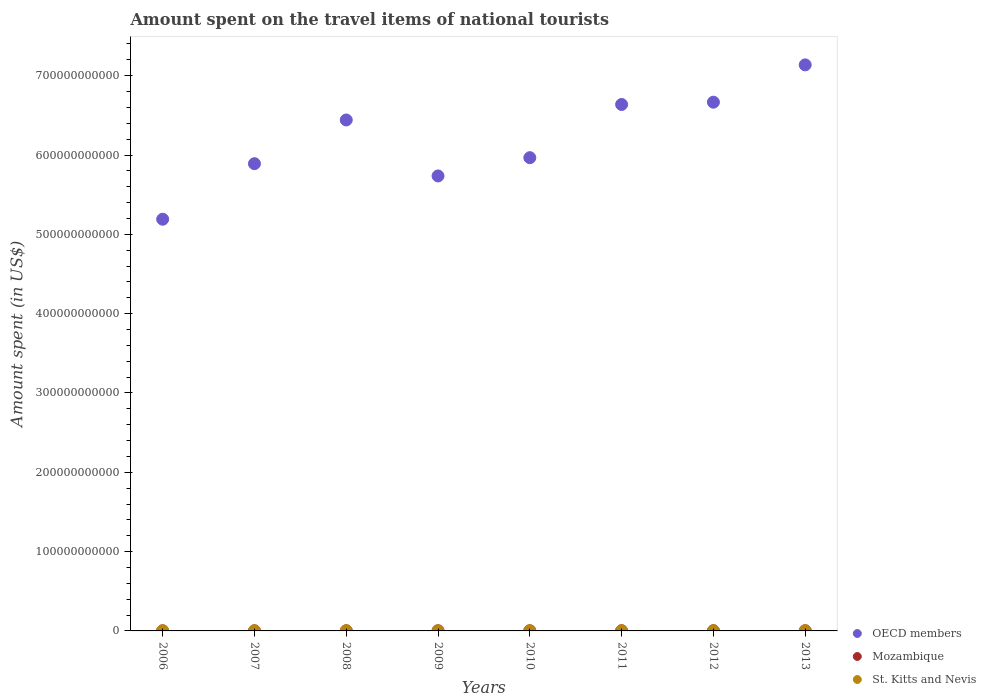How many different coloured dotlines are there?
Ensure brevity in your answer.  3. Is the number of dotlines equal to the number of legend labels?
Offer a terse response. Yes. What is the amount spent on the travel items of national tourists in St. Kitts and Nevis in 2007?
Make the answer very short. 1.25e+08. Across all years, what is the maximum amount spent on the travel items of national tourists in St. Kitts and Nevis?
Ensure brevity in your answer.  1.32e+08. Across all years, what is the minimum amount spent on the travel items of national tourists in St. Kitts and Nevis?
Make the answer very short. 8.30e+07. In which year was the amount spent on the travel items of national tourists in St. Kitts and Nevis maximum?
Your answer should be very brief. 2006. In which year was the amount spent on the travel items of national tourists in OECD members minimum?
Provide a succinct answer. 2006. What is the total amount spent on the travel items of national tourists in St. Kitts and Nevis in the graph?
Offer a terse response. 8.30e+08. What is the difference between the amount spent on the travel items of national tourists in OECD members in 2012 and that in 2013?
Ensure brevity in your answer.  -4.70e+1. What is the difference between the amount spent on the travel items of national tourists in Mozambique in 2013 and the amount spent on the travel items of national tourists in OECD members in 2010?
Give a very brief answer. -5.96e+11. What is the average amount spent on the travel items of national tourists in St. Kitts and Nevis per year?
Provide a short and direct response. 1.04e+08. In the year 2006, what is the difference between the amount spent on the travel items of national tourists in St. Kitts and Nevis and amount spent on the travel items of national tourists in OECD members?
Your answer should be very brief. -5.19e+11. What is the ratio of the amount spent on the travel items of national tourists in Mozambique in 2007 to that in 2009?
Offer a terse response. 0.83. Is the amount spent on the travel items of national tourists in St. Kitts and Nevis in 2009 less than that in 2011?
Offer a very short reply. Yes. What is the difference between the highest and the second highest amount spent on the travel items of national tourists in St. Kitts and Nevis?
Your answer should be compact. 7.00e+06. What is the difference between the highest and the lowest amount spent on the travel items of national tourists in St. Kitts and Nevis?
Ensure brevity in your answer.  4.90e+07. In how many years, is the amount spent on the travel items of national tourists in St. Kitts and Nevis greater than the average amount spent on the travel items of national tourists in St. Kitts and Nevis taken over all years?
Your answer should be very brief. 3. Does the amount spent on the travel items of national tourists in Mozambique monotonically increase over the years?
Offer a very short reply. No. Is the amount spent on the travel items of national tourists in OECD members strictly greater than the amount spent on the travel items of national tourists in St. Kitts and Nevis over the years?
Ensure brevity in your answer.  Yes. How many years are there in the graph?
Give a very brief answer. 8. What is the difference between two consecutive major ticks on the Y-axis?
Provide a short and direct response. 1.00e+11. Does the graph contain any zero values?
Make the answer very short. No. Where does the legend appear in the graph?
Provide a short and direct response. Bottom right. How many legend labels are there?
Your answer should be very brief. 3. What is the title of the graph?
Make the answer very short. Amount spent on the travel items of national tourists. What is the label or title of the Y-axis?
Provide a succinct answer. Amount spent (in US$). What is the Amount spent (in US$) in OECD members in 2006?
Offer a terse response. 5.19e+11. What is the Amount spent (in US$) in Mozambique in 2006?
Provide a short and direct response. 1.40e+08. What is the Amount spent (in US$) of St. Kitts and Nevis in 2006?
Your response must be concise. 1.32e+08. What is the Amount spent (in US$) of OECD members in 2007?
Make the answer very short. 5.89e+11. What is the Amount spent (in US$) in Mozambique in 2007?
Keep it short and to the point. 1.63e+08. What is the Amount spent (in US$) in St. Kitts and Nevis in 2007?
Your answer should be very brief. 1.25e+08. What is the Amount spent (in US$) of OECD members in 2008?
Offer a terse response. 6.44e+11. What is the Amount spent (in US$) in Mozambique in 2008?
Make the answer very short. 1.90e+08. What is the Amount spent (in US$) in St. Kitts and Nevis in 2008?
Offer a very short reply. 1.10e+08. What is the Amount spent (in US$) in OECD members in 2009?
Provide a succinct answer. 5.74e+11. What is the Amount spent (in US$) in Mozambique in 2009?
Provide a succinct answer. 1.96e+08. What is the Amount spent (in US$) in St. Kitts and Nevis in 2009?
Your answer should be very brief. 8.30e+07. What is the Amount spent (in US$) of OECD members in 2010?
Provide a succinct answer. 5.97e+11. What is the Amount spent (in US$) of Mozambique in 2010?
Make the answer very short. 1.97e+08. What is the Amount spent (in US$) in St. Kitts and Nevis in 2010?
Offer a very short reply. 9.00e+07. What is the Amount spent (in US$) of OECD members in 2011?
Offer a terse response. 6.64e+11. What is the Amount spent (in US$) in Mozambique in 2011?
Offer a very short reply. 2.26e+08. What is the Amount spent (in US$) of St. Kitts and Nevis in 2011?
Provide a succinct answer. 9.40e+07. What is the Amount spent (in US$) in OECD members in 2012?
Offer a very short reply. 6.67e+11. What is the Amount spent (in US$) of Mozambique in 2012?
Provide a succinct answer. 2.50e+08. What is the Amount spent (in US$) of St. Kitts and Nevis in 2012?
Your answer should be very brief. 9.50e+07. What is the Amount spent (in US$) in OECD members in 2013?
Provide a short and direct response. 7.14e+11. What is the Amount spent (in US$) of Mozambique in 2013?
Your response must be concise. 2.41e+08. What is the Amount spent (in US$) of St. Kitts and Nevis in 2013?
Provide a short and direct response. 1.01e+08. Across all years, what is the maximum Amount spent (in US$) in OECD members?
Offer a terse response. 7.14e+11. Across all years, what is the maximum Amount spent (in US$) in Mozambique?
Your answer should be compact. 2.50e+08. Across all years, what is the maximum Amount spent (in US$) in St. Kitts and Nevis?
Make the answer very short. 1.32e+08. Across all years, what is the minimum Amount spent (in US$) in OECD members?
Your response must be concise. 5.19e+11. Across all years, what is the minimum Amount spent (in US$) of Mozambique?
Your answer should be compact. 1.40e+08. Across all years, what is the minimum Amount spent (in US$) in St. Kitts and Nevis?
Offer a terse response. 8.30e+07. What is the total Amount spent (in US$) of OECD members in the graph?
Give a very brief answer. 4.97e+12. What is the total Amount spent (in US$) of Mozambique in the graph?
Keep it short and to the point. 1.60e+09. What is the total Amount spent (in US$) in St. Kitts and Nevis in the graph?
Provide a short and direct response. 8.30e+08. What is the difference between the Amount spent (in US$) of OECD members in 2006 and that in 2007?
Provide a succinct answer. -7.00e+1. What is the difference between the Amount spent (in US$) of Mozambique in 2006 and that in 2007?
Offer a very short reply. -2.30e+07. What is the difference between the Amount spent (in US$) of St. Kitts and Nevis in 2006 and that in 2007?
Keep it short and to the point. 7.00e+06. What is the difference between the Amount spent (in US$) of OECD members in 2006 and that in 2008?
Your answer should be very brief. -1.25e+11. What is the difference between the Amount spent (in US$) in Mozambique in 2006 and that in 2008?
Provide a short and direct response. -5.00e+07. What is the difference between the Amount spent (in US$) of St. Kitts and Nevis in 2006 and that in 2008?
Offer a very short reply. 2.20e+07. What is the difference between the Amount spent (in US$) of OECD members in 2006 and that in 2009?
Make the answer very short. -5.46e+1. What is the difference between the Amount spent (in US$) of Mozambique in 2006 and that in 2009?
Give a very brief answer. -5.60e+07. What is the difference between the Amount spent (in US$) of St. Kitts and Nevis in 2006 and that in 2009?
Your response must be concise. 4.90e+07. What is the difference between the Amount spent (in US$) of OECD members in 2006 and that in 2010?
Offer a very short reply. -7.76e+1. What is the difference between the Amount spent (in US$) in Mozambique in 2006 and that in 2010?
Make the answer very short. -5.70e+07. What is the difference between the Amount spent (in US$) in St. Kitts and Nevis in 2006 and that in 2010?
Your answer should be very brief. 4.20e+07. What is the difference between the Amount spent (in US$) of OECD members in 2006 and that in 2011?
Provide a short and direct response. -1.45e+11. What is the difference between the Amount spent (in US$) in Mozambique in 2006 and that in 2011?
Provide a short and direct response. -8.60e+07. What is the difference between the Amount spent (in US$) in St. Kitts and Nevis in 2006 and that in 2011?
Your answer should be very brief. 3.80e+07. What is the difference between the Amount spent (in US$) in OECD members in 2006 and that in 2012?
Give a very brief answer. -1.48e+11. What is the difference between the Amount spent (in US$) of Mozambique in 2006 and that in 2012?
Your answer should be very brief. -1.10e+08. What is the difference between the Amount spent (in US$) of St. Kitts and Nevis in 2006 and that in 2012?
Offer a very short reply. 3.70e+07. What is the difference between the Amount spent (in US$) in OECD members in 2006 and that in 2013?
Offer a terse response. -1.95e+11. What is the difference between the Amount spent (in US$) in Mozambique in 2006 and that in 2013?
Ensure brevity in your answer.  -1.01e+08. What is the difference between the Amount spent (in US$) in St. Kitts and Nevis in 2006 and that in 2013?
Make the answer very short. 3.10e+07. What is the difference between the Amount spent (in US$) in OECD members in 2007 and that in 2008?
Provide a succinct answer. -5.51e+1. What is the difference between the Amount spent (in US$) of Mozambique in 2007 and that in 2008?
Provide a short and direct response. -2.70e+07. What is the difference between the Amount spent (in US$) in St. Kitts and Nevis in 2007 and that in 2008?
Keep it short and to the point. 1.50e+07. What is the difference between the Amount spent (in US$) of OECD members in 2007 and that in 2009?
Offer a very short reply. 1.55e+1. What is the difference between the Amount spent (in US$) in Mozambique in 2007 and that in 2009?
Offer a very short reply. -3.30e+07. What is the difference between the Amount spent (in US$) in St. Kitts and Nevis in 2007 and that in 2009?
Offer a terse response. 4.20e+07. What is the difference between the Amount spent (in US$) of OECD members in 2007 and that in 2010?
Offer a terse response. -7.57e+09. What is the difference between the Amount spent (in US$) of Mozambique in 2007 and that in 2010?
Provide a succinct answer. -3.40e+07. What is the difference between the Amount spent (in US$) of St. Kitts and Nevis in 2007 and that in 2010?
Offer a very short reply. 3.50e+07. What is the difference between the Amount spent (in US$) in OECD members in 2007 and that in 2011?
Give a very brief answer. -7.46e+1. What is the difference between the Amount spent (in US$) of Mozambique in 2007 and that in 2011?
Provide a short and direct response. -6.30e+07. What is the difference between the Amount spent (in US$) of St. Kitts and Nevis in 2007 and that in 2011?
Your answer should be very brief. 3.10e+07. What is the difference between the Amount spent (in US$) in OECD members in 2007 and that in 2012?
Your response must be concise. -7.75e+1. What is the difference between the Amount spent (in US$) in Mozambique in 2007 and that in 2012?
Your response must be concise. -8.70e+07. What is the difference between the Amount spent (in US$) in St. Kitts and Nevis in 2007 and that in 2012?
Make the answer very short. 3.00e+07. What is the difference between the Amount spent (in US$) in OECD members in 2007 and that in 2013?
Provide a short and direct response. -1.25e+11. What is the difference between the Amount spent (in US$) of Mozambique in 2007 and that in 2013?
Give a very brief answer. -7.80e+07. What is the difference between the Amount spent (in US$) of St. Kitts and Nevis in 2007 and that in 2013?
Keep it short and to the point. 2.40e+07. What is the difference between the Amount spent (in US$) of OECD members in 2008 and that in 2009?
Make the answer very short. 7.06e+1. What is the difference between the Amount spent (in US$) of Mozambique in 2008 and that in 2009?
Ensure brevity in your answer.  -6.00e+06. What is the difference between the Amount spent (in US$) of St. Kitts and Nevis in 2008 and that in 2009?
Offer a very short reply. 2.70e+07. What is the difference between the Amount spent (in US$) of OECD members in 2008 and that in 2010?
Give a very brief answer. 4.75e+1. What is the difference between the Amount spent (in US$) in Mozambique in 2008 and that in 2010?
Your answer should be very brief. -7.00e+06. What is the difference between the Amount spent (in US$) in St. Kitts and Nevis in 2008 and that in 2010?
Offer a very short reply. 2.00e+07. What is the difference between the Amount spent (in US$) of OECD members in 2008 and that in 2011?
Keep it short and to the point. -1.95e+1. What is the difference between the Amount spent (in US$) in Mozambique in 2008 and that in 2011?
Your answer should be compact. -3.60e+07. What is the difference between the Amount spent (in US$) of St. Kitts and Nevis in 2008 and that in 2011?
Make the answer very short. 1.60e+07. What is the difference between the Amount spent (in US$) of OECD members in 2008 and that in 2012?
Ensure brevity in your answer.  -2.24e+1. What is the difference between the Amount spent (in US$) in Mozambique in 2008 and that in 2012?
Your answer should be compact. -6.00e+07. What is the difference between the Amount spent (in US$) of St. Kitts and Nevis in 2008 and that in 2012?
Ensure brevity in your answer.  1.50e+07. What is the difference between the Amount spent (in US$) of OECD members in 2008 and that in 2013?
Offer a terse response. -6.95e+1. What is the difference between the Amount spent (in US$) of Mozambique in 2008 and that in 2013?
Provide a short and direct response. -5.10e+07. What is the difference between the Amount spent (in US$) in St. Kitts and Nevis in 2008 and that in 2013?
Offer a terse response. 9.00e+06. What is the difference between the Amount spent (in US$) in OECD members in 2009 and that in 2010?
Offer a very short reply. -2.30e+1. What is the difference between the Amount spent (in US$) of St. Kitts and Nevis in 2009 and that in 2010?
Ensure brevity in your answer.  -7.00e+06. What is the difference between the Amount spent (in US$) of OECD members in 2009 and that in 2011?
Your answer should be very brief. -9.01e+1. What is the difference between the Amount spent (in US$) in Mozambique in 2009 and that in 2011?
Ensure brevity in your answer.  -3.00e+07. What is the difference between the Amount spent (in US$) in St. Kitts and Nevis in 2009 and that in 2011?
Provide a succinct answer. -1.10e+07. What is the difference between the Amount spent (in US$) in OECD members in 2009 and that in 2012?
Make the answer very short. -9.30e+1. What is the difference between the Amount spent (in US$) in Mozambique in 2009 and that in 2012?
Provide a succinct answer. -5.40e+07. What is the difference between the Amount spent (in US$) of St. Kitts and Nevis in 2009 and that in 2012?
Keep it short and to the point. -1.20e+07. What is the difference between the Amount spent (in US$) of OECD members in 2009 and that in 2013?
Keep it short and to the point. -1.40e+11. What is the difference between the Amount spent (in US$) in Mozambique in 2009 and that in 2013?
Offer a terse response. -4.50e+07. What is the difference between the Amount spent (in US$) of St. Kitts and Nevis in 2009 and that in 2013?
Your response must be concise. -1.80e+07. What is the difference between the Amount spent (in US$) in OECD members in 2010 and that in 2011?
Ensure brevity in your answer.  -6.71e+1. What is the difference between the Amount spent (in US$) of Mozambique in 2010 and that in 2011?
Provide a succinct answer. -2.90e+07. What is the difference between the Amount spent (in US$) of OECD members in 2010 and that in 2012?
Ensure brevity in your answer.  -7.00e+1. What is the difference between the Amount spent (in US$) in Mozambique in 2010 and that in 2012?
Keep it short and to the point. -5.30e+07. What is the difference between the Amount spent (in US$) of St. Kitts and Nevis in 2010 and that in 2012?
Your answer should be very brief. -5.00e+06. What is the difference between the Amount spent (in US$) of OECD members in 2010 and that in 2013?
Offer a terse response. -1.17e+11. What is the difference between the Amount spent (in US$) of Mozambique in 2010 and that in 2013?
Your answer should be compact. -4.40e+07. What is the difference between the Amount spent (in US$) in St. Kitts and Nevis in 2010 and that in 2013?
Keep it short and to the point. -1.10e+07. What is the difference between the Amount spent (in US$) of OECD members in 2011 and that in 2012?
Provide a succinct answer. -2.89e+09. What is the difference between the Amount spent (in US$) of Mozambique in 2011 and that in 2012?
Your answer should be very brief. -2.40e+07. What is the difference between the Amount spent (in US$) of OECD members in 2011 and that in 2013?
Your answer should be compact. -4.99e+1. What is the difference between the Amount spent (in US$) of Mozambique in 2011 and that in 2013?
Provide a short and direct response. -1.50e+07. What is the difference between the Amount spent (in US$) in St. Kitts and Nevis in 2011 and that in 2013?
Offer a very short reply. -7.00e+06. What is the difference between the Amount spent (in US$) in OECD members in 2012 and that in 2013?
Provide a succinct answer. -4.70e+1. What is the difference between the Amount spent (in US$) of Mozambique in 2012 and that in 2013?
Provide a succinct answer. 9.00e+06. What is the difference between the Amount spent (in US$) in St. Kitts and Nevis in 2012 and that in 2013?
Keep it short and to the point. -6.00e+06. What is the difference between the Amount spent (in US$) of OECD members in 2006 and the Amount spent (in US$) of Mozambique in 2007?
Your response must be concise. 5.19e+11. What is the difference between the Amount spent (in US$) in OECD members in 2006 and the Amount spent (in US$) in St. Kitts and Nevis in 2007?
Keep it short and to the point. 5.19e+11. What is the difference between the Amount spent (in US$) of Mozambique in 2006 and the Amount spent (in US$) of St. Kitts and Nevis in 2007?
Ensure brevity in your answer.  1.50e+07. What is the difference between the Amount spent (in US$) in OECD members in 2006 and the Amount spent (in US$) in Mozambique in 2008?
Your response must be concise. 5.19e+11. What is the difference between the Amount spent (in US$) in OECD members in 2006 and the Amount spent (in US$) in St. Kitts and Nevis in 2008?
Your answer should be compact. 5.19e+11. What is the difference between the Amount spent (in US$) of Mozambique in 2006 and the Amount spent (in US$) of St. Kitts and Nevis in 2008?
Your answer should be very brief. 3.00e+07. What is the difference between the Amount spent (in US$) in OECD members in 2006 and the Amount spent (in US$) in Mozambique in 2009?
Keep it short and to the point. 5.19e+11. What is the difference between the Amount spent (in US$) of OECD members in 2006 and the Amount spent (in US$) of St. Kitts and Nevis in 2009?
Keep it short and to the point. 5.19e+11. What is the difference between the Amount spent (in US$) in Mozambique in 2006 and the Amount spent (in US$) in St. Kitts and Nevis in 2009?
Ensure brevity in your answer.  5.70e+07. What is the difference between the Amount spent (in US$) in OECD members in 2006 and the Amount spent (in US$) in Mozambique in 2010?
Ensure brevity in your answer.  5.19e+11. What is the difference between the Amount spent (in US$) of OECD members in 2006 and the Amount spent (in US$) of St. Kitts and Nevis in 2010?
Ensure brevity in your answer.  5.19e+11. What is the difference between the Amount spent (in US$) of Mozambique in 2006 and the Amount spent (in US$) of St. Kitts and Nevis in 2010?
Offer a very short reply. 5.00e+07. What is the difference between the Amount spent (in US$) of OECD members in 2006 and the Amount spent (in US$) of Mozambique in 2011?
Your answer should be very brief. 5.19e+11. What is the difference between the Amount spent (in US$) in OECD members in 2006 and the Amount spent (in US$) in St. Kitts and Nevis in 2011?
Provide a short and direct response. 5.19e+11. What is the difference between the Amount spent (in US$) of Mozambique in 2006 and the Amount spent (in US$) of St. Kitts and Nevis in 2011?
Keep it short and to the point. 4.60e+07. What is the difference between the Amount spent (in US$) in OECD members in 2006 and the Amount spent (in US$) in Mozambique in 2012?
Provide a short and direct response. 5.19e+11. What is the difference between the Amount spent (in US$) of OECD members in 2006 and the Amount spent (in US$) of St. Kitts and Nevis in 2012?
Your response must be concise. 5.19e+11. What is the difference between the Amount spent (in US$) in Mozambique in 2006 and the Amount spent (in US$) in St. Kitts and Nevis in 2012?
Provide a short and direct response. 4.50e+07. What is the difference between the Amount spent (in US$) of OECD members in 2006 and the Amount spent (in US$) of Mozambique in 2013?
Provide a short and direct response. 5.19e+11. What is the difference between the Amount spent (in US$) of OECD members in 2006 and the Amount spent (in US$) of St. Kitts and Nevis in 2013?
Provide a succinct answer. 5.19e+11. What is the difference between the Amount spent (in US$) in Mozambique in 2006 and the Amount spent (in US$) in St. Kitts and Nevis in 2013?
Your answer should be compact. 3.90e+07. What is the difference between the Amount spent (in US$) of OECD members in 2007 and the Amount spent (in US$) of Mozambique in 2008?
Your answer should be compact. 5.89e+11. What is the difference between the Amount spent (in US$) of OECD members in 2007 and the Amount spent (in US$) of St. Kitts and Nevis in 2008?
Provide a succinct answer. 5.89e+11. What is the difference between the Amount spent (in US$) of Mozambique in 2007 and the Amount spent (in US$) of St. Kitts and Nevis in 2008?
Provide a short and direct response. 5.30e+07. What is the difference between the Amount spent (in US$) of OECD members in 2007 and the Amount spent (in US$) of Mozambique in 2009?
Offer a very short reply. 5.89e+11. What is the difference between the Amount spent (in US$) in OECD members in 2007 and the Amount spent (in US$) in St. Kitts and Nevis in 2009?
Your response must be concise. 5.89e+11. What is the difference between the Amount spent (in US$) of Mozambique in 2007 and the Amount spent (in US$) of St. Kitts and Nevis in 2009?
Ensure brevity in your answer.  8.00e+07. What is the difference between the Amount spent (in US$) in OECD members in 2007 and the Amount spent (in US$) in Mozambique in 2010?
Provide a succinct answer. 5.89e+11. What is the difference between the Amount spent (in US$) in OECD members in 2007 and the Amount spent (in US$) in St. Kitts and Nevis in 2010?
Provide a succinct answer. 5.89e+11. What is the difference between the Amount spent (in US$) in Mozambique in 2007 and the Amount spent (in US$) in St. Kitts and Nevis in 2010?
Your answer should be very brief. 7.30e+07. What is the difference between the Amount spent (in US$) of OECD members in 2007 and the Amount spent (in US$) of Mozambique in 2011?
Keep it short and to the point. 5.89e+11. What is the difference between the Amount spent (in US$) in OECD members in 2007 and the Amount spent (in US$) in St. Kitts and Nevis in 2011?
Offer a terse response. 5.89e+11. What is the difference between the Amount spent (in US$) in Mozambique in 2007 and the Amount spent (in US$) in St. Kitts and Nevis in 2011?
Keep it short and to the point. 6.90e+07. What is the difference between the Amount spent (in US$) in OECD members in 2007 and the Amount spent (in US$) in Mozambique in 2012?
Offer a very short reply. 5.89e+11. What is the difference between the Amount spent (in US$) in OECD members in 2007 and the Amount spent (in US$) in St. Kitts and Nevis in 2012?
Make the answer very short. 5.89e+11. What is the difference between the Amount spent (in US$) in Mozambique in 2007 and the Amount spent (in US$) in St. Kitts and Nevis in 2012?
Offer a very short reply. 6.80e+07. What is the difference between the Amount spent (in US$) of OECD members in 2007 and the Amount spent (in US$) of Mozambique in 2013?
Offer a terse response. 5.89e+11. What is the difference between the Amount spent (in US$) of OECD members in 2007 and the Amount spent (in US$) of St. Kitts and Nevis in 2013?
Offer a very short reply. 5.89e+11. What is the difference between the Amount spent (in US$) of Mozambique in 2007 and the Amount spent (in US$) of St. Kitts and Nevis in 2013?
Your response must be concise. 6.20e+07. What is the difference between the Amount spent (in US$) in OECD members in 2008 and the Amount spent (in US$) in Mozambique in 2009?
Provide a succinct answer. 6.44e+11. What is the difference between the Amount spent (in US$) of OECD members in 2008 and the Amount spent (in US$) of St. Kitts and Nevis in 2009?
Your response must be concise. 6.44e+11. What is the difference between the Amount spent (in US$) in Mozambique in 2008 and the Amount spent (in US$) in St. Kitts and Nevis in 2009?
Your answer should be very brief. 1.07e+08. What is the difference between the Amount spent (in US$) in OECD members in 2008 and the Amount spent (in US$) in Mozambique in 2010?
Provide a succinct answer. 6.44e+11. What is the difference between the Amount spent (in US$) in OECD members in 2008 and the Amount spent (in US$) in St. Kitts and Nevis in 2010?
Provide a succinct answer. 6.44e+11. What is the difference between the Amount spent (in US$) in Mozambique in 2008 and the Amount spent (in US$) in St. Kitts and Nevis in 2010?
Your answer should be compact. 1.00e+08. What is the difference between the Amount spent (in US$) of OECD members in 2008 and the Amount spent (in US$) of Mozambique in 2011?
Offer a terse response. 6.44e+11. What is the difference between the Amount spent (in US$) in OECD members in 2008 and the Amount spent (in US$) in St. Kitts and Nevis in 2011?
Your answer should be compact. 6.44e+11. What is the difference between the Amount spent (in US$) in Mozambique in 2008 and the Amount spent (in US$) in St. Kitts and Nevis in 2011?
Your answer should be compact. 9.60e+07. What is the difference between the Amount spent (in US$) in OECD members in 2008 and the Amount spent (in US$) in Mozambique in 2012?
Offer a very short reply. 6.44e+11. What is the difference between the Amount spent (in US$) of OECD members in 2008 and the Amount spent (in US$) of St. Kitts and Nevis in 2012?
Ensure brevity in your answer.  6.44e+11. What is the difference between the Amount spent (in US$) in Mozambique in 2008 and the Amount spent (in US$) in St. Kitts and Nevis in 2012?
Make the answer very short. 9.50e+07. What is the difference between the Amount spent (in US$) of OECD members in 2008 and the Amount spent (in US$) of Mozambique in 2013?
Offer a terse response. 6.44e+11. What is the difference between the Amount spent (in US$) in OECD members in 2008 and the Amount spent (in US$) in St. Kitts and Nevis in 2013?
Make the answer very short. 6.44e+11. What is the difference between the Amount spent (in US$) in Mozambique in 2008 and the Amount spent (in US$) in St. Kitts and Nevis in 2013?
Your response must be concise. 8.90e+07. What is the difference between the Amount spent (in US$) of OECD members in 2009 and the Amount spent (in US$) of Mozambique in 2010?
Ensure brevity in your answer.  5.73e+11. What is the difference between the Amount spent (in US$) of OECD members in 2009 and the Amount spent (in US$) of St. Kitts and Nevis in 2010?
Your response must be concise. 5.74e+11. What is the difference between the Amount spent (in US$) in Mozambique in 2009 and the Amount spent (in US$) in St. Kitts and Nevis in 2010?
Ensure brevity in your answer.  1.06e+08. What is the difference between the Amount spent (in US$) in OECD members in 2009 and the Amount spent (in US$) in Mozambique in 2011?
Your answer should be compact. 5.73e+11. What is the difference between the Amount spent (in US$) of OECD members in 2009 and the Amount spent (in US$) of St. Kitts and Nevis in 2011?
Offer a very short reply. 5.74e+11. What is the difference between the Amount spent (in US$) of Mozambique in 2009 and the Amount spent (in US$) of St. Kitts and Nevis in 2011?
Keep it short and to the point. 1.02e+08. What is the difference between the Amount spent (in US$) of OECD members in 2009 and the Amount spent (in US$) of Mozambique in 2012?
Provide a short and direct response. 5.73e+11. What is the difference between the Amount spent (in US$) in OECD members in 2009 and the Amount spent (in US$) in St. Kitts and Nevis in 2012?
Your answer should be compact. 5.74e+11. What is the difference between the Amount spent (in US$) in Mozambique in 2009 and the Amount spent (in US$) in St. Kitts and Nevis in 2012?
Provide a short and direct response. 1.01e+08. What is the difference between the Amount spent (in US$) of OECD members in 2009 and the Amount spent (in US$) of Mozambique in 2013?
Your response must be concise. 5.73e+11. What is the difference between the Amount spent (in US$) of OECD members in 2009 and the Amount spent (in US$) of St. Kitts and Nevis in 2013?
Provide a short and direct response. 5.74e+11. What is the difference between the Amount spent (in US$) of Mozambique in 2009 and the Amount spent (in US$) of St. Kitts and Nevis in 2013?
Provide a succinct answer. 9.50e+07. What is the difference between the Amount spent (in US$) of OECD members in 2010 and the Amount spent (in US$) of Mozambique in 2011?
Make the answer very short. 5.96e+11. What is the difference between the Amount spent (in US$) of OECD members in 2010 and the Amount spent (in US$) of St. Kitts and Nevis in 2011?
Ensure brevity in your answer.  5.97e+11. What is the difference between the Amount spent (in US$) in Mozambique in 2010 and the Amount spent (in US$) in St. Kitts and Nevis in 2011?
Make the answer very short. 1.03e+08. What is the difference between the Amount spent (in US$) in OECD members in 2010 and the Amount spent (in US$) in Mozambique in 2012?
Make the answer very short. 5.96e+11. What is the difference between the Amount spent (in US$) of OECD members in 2010 and the Amount spent (in US$) of St. Kitts and Nevis in 2012?
Make the answer very short. 5.97e+11. What is the difference between the Amount spent (in US$) of Mozambique in 2010 and the Amount spent (in US$) of St. Kitts and Nevis in 2012?
Offer a terse response. 1.02e+08. What is the difference between the Amount spent (in US$) of OECD members in 2010 and the Amount spent (in US$) of Mozambique in 2013?
Your response must be concise. 5.96e+11. What is the difference between the Amount spent (in US$) of OECD members in 2010 and the Amount spent (in US$) of St. Kitts and Nevis in 2013?
Ensure brevity in your answer.  5.97e+11. What is the difference between the Amount spent (in US$) of Mozambique in 2010 and the Amount spent (in US$) of St. Kitts and Nevis in 2013?
Your response must be concise. 9.60e+07. What is the difference between the Amount spent (in US$) of OECD members in 2011 and the Amount spent (in US$) of Mozambique in 2012?
Provide a short and direct response. 6.63e+11. What is the difference between the Amount spent (in US$) in OECD members in 2011 and the Amount spent (in US$) in St. Kitts and Nevis in 2012?
Your response must be concise. 6.64e+11. What is the difference between the Amount spent (in US$) in Mozambique in 2011 and the Amount spent (in US$) in St. Kitts and Nevis in 2012?
Offer a very short reply. 1.31e+08. What is the difference between the Amount spent (in US$) of OECD members in 2011 and the Amount spent (in US$) of Mozambique in 2013?
Keep it short and to the point. 6.63e+11. What is the difference between the Amount spent (in US$) of OECD members in 2011 and the Amount spent (in US$) of St. Kitts and Nevis in 2013?
Provide a succinct answer. 6.64e+11. What is the difference between the Amount spent (in US$) of Mozambique in 2011 and the Amount spent (in US$) of St. Kitts and Nevis in 2013?
Make the answer very short. 1.25e+08. What is the difference between the Amount spent (in US$) of OECD members in 2012 and the Amount spent (in US$) of Mozambique in 2013?
Ensure brevity in your answer.  6.66e+11. What is the difference between the Amount spent (in US$) in OECD members in 2012 and the Amount spent (in US$) in St. Kitts and Nevis in 2013?
Ensure brevity in your answer.  6.66e+11. What is the difference between the Amount spent (in US$) in Mozambique in 2012 and the Amount spent (in US$) in St. Kitts and Nevis in 2013?
Keep it short and to the point. 1.49e+08. What is the average Amount spent (in US$) in OECD members per year?
Ensure brevity in your answer.  6.21e+11. What is the average Amount spent (in US$) of Mozambique per year?
Keep it short and to the point. 2.00e+08. What is the average Amount spent (in US$) of St. Kitts and Nevis per year?
Provide a short and direct response. 1.04e+08. In the year 2006, what is the difference between the Amount spent (in US$) in OECD members and Amount spent (in US$) in Mozambique?
Make the answer very short. 5.19e+11. In the year 2006, what is the difference between the Amount spent (in US$) of OECD members and Amount spent (in US$) of St. Kitts and Nevis?
Make the answer very short. 5.19e+11. In the year 2006, what is the difference between the Amount spent (in US$) of Mozambique and Amount spent (in US$) of St. Kitts and Nevis?
Provide a succinct answer. 8.00e+06. In the year 2007, what is the difference between the Amount spent (in US$) of OECD members and Amount spent (in US$) of Mozambique?
Make the answer very short. 5.89e+11. In the year 2007, what is the difference between the Amount spent (in US$) of OECD members and Amount spent (in US$) of St. Kitts and Nevis?
Provide a succinct answer. 5.89e+11. In the year 2007, what is the difference between the Amount spent (in US$) of Mozambique and Amount spent (in US$) of St. Kitts and Nevis?
Your answer should be very brief. 3.80e+07. In the year 2008, what is the difference between the Amount spent (in US$) of OECD members and Amount spent (in US$) of Mozambique?
Provide a short and direct response. 6.44e+11. In the year 2008, what is the difference between the Amount spent (in US$) of OECD members and Amount spent (in US$) of St. Kitts and Nevis?
Keep it short and to the point. 6.44e+11. In the year 2008, what is the difference between the Amount spent (in US$) of Mozambique and Amount spent (in US$) of St. Kitts and Nevis?
Keep it short and to the point. 8.00e+07. In the year 2009, what is the difference between the Amount spent (in US$) of OECD members and Amount spent (in US$) of Mozambique?
Offer a very short reply. 5.73e+11. In the year 2009, what is the difference between the Amount spent (in US$) in OECD members and Amount spent (in US$) in St. Kitts and Nevis?
Provide a short and direct response. 5.74e+11. In the year 2009, what is the difference between the Amount spent (in US$) of Mozambique and Amount spent (in US$) of St. Kitts and Nevis?
Ensure brevity in your answer.  1.13e+08. In the year 2010, what is the difference between the Amount spent (in US$) of OECD members and Amount spent (in US$) of Mozambique?
Keep it short and to the point. 5.96e+11. In the year 2010, what is the difference between the Amount spent (in US$) in OECD members and Amount spent (in US$) in St. Kitts and Nevis?
Your answer should be very brief. 5.97e+11. In the year 2010, what is the difference between the Amount spent (in US$) of Mozambique and Amount spent (in US$) of St. Kitts and Nevis?
Give a very brief answer. 1.07e+08. In the year 2011, what is the difference between the Amount spent (in US$) in OECD members and Amount spent (in US$) in Mozambique?
Make the answer very short. 6.63e+11. In the year 2011, what is the difference between the Amount spent (in US$) in OECD members and Amount spent (in US$) in St. Kitts and Nevis?
Offer a very short reply. 6.64e+11. In the year 2011, what is the difference between the Amount spent (in US$) of Mozambique and Amount spent (in US$) of St. Kitts and Nevis?
Make the answer very short. 1.32e+08. In the year 2012, what is the difference between the Amount spent (in US$) in OECD members and Amount spent (in US$) in Mozambique?
Give a very brief answer. 6.66e+11. In the year 2012, what is the difference between the Amount spent (in US$) in OECD members and Amount spent (in US$) in St. Kitts and Nevis?
Provide a succinct answer. 6.66e+11. In the year 2012, what is the difference between the Amount spent (in US$) of Mozambique and Amount spent (in US$) of St. Kitts and Nevis?
Provide a short and direct response. 1.55e+08. In the year 2013, what is the difference between the Amount spent (in US$) in OECD members and Amount spent (in US$) in Mozambique?
Your answer should be very brief. 7.13e+11. In the year 2013, what is the difference between the Amount spent (in US$) of OECD members and Amount spent (in US$) of St. Kitts and Nevis?
Keep it short and to the point. 7.14e+11. In the year 2013, what is the difference between the Amount spent (in US$) of Mozambique and Amount spent (in US$) of St. Kitts and Nevis?
Your answer should be very brief. 1.40e+08. What is the ratio of the Amount spent (in US$) in OECD members in 2006 to that in 2007?
Ensure brevity in your answer.  0.88. What is the ratio of the Amount spent (in US$) in Mozambique in 2006 to that in 2007?
Provide a succinct answer. 0.86. What is the ratio of the Amount spent (in US$) of St. Kitts and Nevis in 2006 to that in 2007?
Provide a short and direct response. 1.06. What is the ratio of the Amount spent (in US$) of OECD members in 2006 to that in 2008?
Your response must be concise. 0.81. What is the ratio of the Amount spent (in US$) of Mozambique in 2006 to that in 2008?
Make the answer very short. 0.74. What is the ratio of the Amount spent (in US$) in St. Kitts and Nevis in 2006 to that in 2008?
Offer a terse response. 1.2. What is the ratio of the Amount spent (in US$) in OECD members in 2006 to that in 2009?
Offer a terse response. 0.9. What is the ratio of the Amount spent (in US$) of St. Kitts and Nevis in 2006 to that in 2009?
Provide a succinct answer. 1.59. What is the ratio of the Amount spent (in US$) of OECD members in 2006 to that in 2010?
Your response must be concise. 0.87. What is the ratio of the Amount spent (in US$) of Mozambique in 2006 to that in 2010?
Provide a succinct answer. 0.71. What is the ratio of the Amount spent (in US$) in St. Kitts and Nevis in 2006 to that in 2010?
Provide a succinct answer. 1.47. What is the ratio of the Amount spent (in US$) in OECD members in 2006 to that in 2011?
Keep it short and to the point. 0.78. What is the ratio of the Amount spent (in US$) in Mozambique in 2006 to that in 2011?
Keep it short and to the point. 0.62. What is the ratio of the Amount spent (in US$) of St. Kitts and Nevis in 2006 to that in 2011?
Provide a short and direct response. 1.4. What is the ratio of the Amount spent (in US$) of OECD members in 2006 to that in 2012?
Offer a very short reply. 0.78. What is the ratio of the Amount spent (in US$) in Mozambique in 2006 to that in 2012?
Offer a very short reply. 0.56. What is the ratio of the Amount spent (in US$) in St. Kitts and Nevis in 2006 to that in 2012?
Make the answer very short. 1.39. What is the ratio of the Amount spent (in US$) of OECD members in 2006 to that in 2013?
Offer a terse response. 0.73. What is the ratio of the Amount spent (in US$) in Mozambique in 2006 to that in 2013?
Offer a terse response. 0.58. What is the ratio of the Amount spent (in US$) in St. Kitts and Nevis in 2006 to that in 2013?
Ensure brevity in your answer.  1.31. What is the ratio of the Amount spent (in US$) in OECD members in 2007 to that in 2008?
Offer a very short reply. 0.91. What is the ratio of the Amount spent (in US$) of Mozambique in 2007 to that in 2008?
Offer a very short reply. 0.86. What is the ratio of the Amount spent (in US$) in St. Kitts and Nevis in 2007 to that in 2008?
Keep it short and to the point. 1.14. What is the ratio of the Amount spent (in US$) of Mozambique in 2007 to that in 2009?
Offer a very short reply. 0.83. What is the ratio of the Amount spent (in US$) of St. Kitts and Nevis in 2007 to that in 2009?
Your answer should be very brief. 1.51. What is the ratio of the Amount spent (in US$) of OECD members in 2007 to that in 2010?
Offer a terse response. 0.99. What is the ratio of the Amount spent (in US$) in Mozambique in 2007 to that in 2010?
Offer a very short reply. 0.83. What is the ratio of the Amount spent (in US$) of St. Kitts and Nevis in 2007 to that in 2010?
Make the answer very short. 1.39. What is the ratio of the Amount spent (in US$) of OECD members in 2007 to that in 2011?
Ensure brevity in your answer.  0.89. What is the ratio of the Amount spent (in US$) of Mozambique in 2007 to that in 2011?
Offer a terse response. 0.72. What is the ratio of the Amount spent (in US$) in St. Kitts and Nevis in 2007 to that in 2011?
Offer a terse response. 1.33. What is the ratio of the Amount spent (in US$) of OECD members in 2007 to that in 2012?
Offer a very short reply. 0.88. What is the ratio of the Amount spent (in US$) of Mozambique in 2007 to that in 2012?
Your answer should be very brief. 0.65. What is the ratio of the Amount spent (in US$) of St. Kitts and Nevis in 2007 to that in 2012?
Offer a terse response. 1.32. What is the ratio of the Amount spent (in US$) of OECD members in 2007 to that in 2013?
Give a very brief answer. 0.83. What is the ratio of the Amount spent (in US$) of Mozambique in 2007 to that in 2013?
Your answer should be very brief. 0.68. What is the ratio of the Amount spent (in US$) in St. Kitts and Nevis in 2007 to that in 2013?
Ensure brevity in your answer.  1.24. What is the ratio of the Amount spent (in US$) of OECD members in 2008 to that in 2009?
Give a very brief answer. 1.12. What is the ratio of the Amount spent (in US$) in Mozambique in 2008 to that in 2009?
Your answer should be compact. 0.97. What is the ratio of the Amount spent (in US$) in St. Kitts and Nevis in 2008 to that in 2009?
Your answer should be very brief. 1.33. What is the ratio of the Amount spent (in US$) in OECD members in 2008 to that in 2010?
Make the answer very short. 1.08. What is the ratio of the Amount spent (in US$) of Mozambique in 2008 to that in 2010?
Your answer should be compact. 0.96. What is the ratio of the Amount spent (in US$) of St. Kitts and Nevis in 2008 to that in 2010?
Ensure brevity in your answer.  1.22. What is the ratio of the Amount spent (in US$) of OECD members in 2008 to that in 2011?
Keep it short and to the point. 0.97. What is the ratio of the Amount spent (in US$) in Mozambique in 2008 to that in 2011?
Offer a very short reply. 0.84. What is the ratio of the Amount spent (in US$) of St. Kitts and Nevis in 2008 to that in 2011?
Your answer should be compact. 1.17. What is the ratio of the Amount spent (in US$) of OECD members in 2008 to that in 2012?
Your answer should be very brief. 0.97. What is the ratio of the Amount spent (in US$) of Mozambique in 2008 to that in 2012?
Your answer should be compact. 0.76. What is the ratio of the Amount spent (in US$) in St. Kitts and Nevis in 2008 to that in 2012?
Ensure brevity in your answer.  1.16. What is the ratio of the Amount spent (in US$) of OECD members in 2008 to that in 2013?
Your response must be concise. 0.9. What is the ratio of the Amount spent (in US$) of Mozambique in 2008 to that in 2013?
Make the answer very short. 0.79. What is the ratio of the Amount spent (in US$) of St. Kitts and Nevis in 2008 to that in 2013?
Give a very brief answer. 1.09. What is the ratio of the Amount spent (in US$) in OECD members in 2009 to that in 2010?
Provide a succinct answer. 0.96. What is the ratio of the Amount spent (in US$) in Mozambique in 2009 to that in 2010?
Provide a succinct answer. 0.99. What is the ratio of the Amount spent (in US$) in St. Kitts and Nevis in 2009 to that in 2010?
Keep it short and to the point. 0.92. What is the ratio of the Amount spent (in US$) of OECD members in 2009 to that in 2011?
Ensure brevity in your answer.  0.86. What is the ratio of the Amount spent (in US$) of Mozambique in 2009 to that in 2011?
Make the answer very short. 0.87. What is the ratio of the Amount spent (in US$) in St. Kitts and Nevis in 2009 to that in 2011?
Offer a very short reply. 0.88. What is the ratio of the Amount spent (in US$) of OECD members in 2009 to that in 2012?
Offer a very short reply. 0.86. What is the ratio of the Amount spent (in US$) in Mozambique in 2009 to that in 2012?
Your response must be concise. 0.78. What is the ratio of the Amount spent (in US$) of St. Kitts and Nevis in 2009 to that in 2012?
Provide a succinct answer. 0.87. What is the ratio of the Amount spent (in US$) of OECD members in 2009 to that in 2013?
Offer a very short reply. 0.8. What is the ratio of the Amount spent (in US$) of Mozambique in 2009 to that in 2013?
Give a very brief answer. 0.81. What is the ratio of the Amount spent (in US$) of St. Kitts and Nevis in 2009 to that in 2013?
Provide a succinct answer. 0.82. What is the ratio of the Amount spent (in US$) of OECD members in 2010 to that in 2011?
Offer a very short reply. 0.9. What is the ratio of the Amount spent (in US$) in Mozambique in 2010 to that in 2011?
Provide a succinct answer. 0.87. What is the ratio of the Amount spent (in US$) in St. Kitts and Nevis in 2010 to that in 2011?
Provide a short and direct response. 0.96. What is the ratio of the Amount spent (in US$) in OECD members in 2010 to that in 2012?
Make the answer very short. 0.9. What is the ratio of the Amount spent (in US$) of Mozambique in 2010 to that in 2012?
Give a very brief answer. 0.79. What is the ratio of the Amount spent (in US$) of St. Kitts and Nevis in 2010 to that in 2012?
Keep it short and to the point. 0.95. What is the ratio of the Amount spent (in US$) in OECD members in 2010 to that in 2013?
Make the answer very short. 0.84. What is the ratio of the Amount spent (in US$) of Mozambique in 2010 to that in 2013?
Provide a short and direct response. 0.82. What is the ratio of the Amount spent (in US$) in St. Kitts and Nevis in 2010 to that in 2013?
Keep it short and to the point. 0.89. What is the ratio of the Amount spent (in US$) in OECD members in 2011 to that in 2012?
Your answer should be very brief. 1. What is the ratio of the Amount spent (in US$) of Mozambique in 2011 to that in 2012?
Offer a terse response. 0.9. What is the ratio of the Amount spent (in US$) in Mozambique in 2011 to that in 2013?
Your response must be concise. 0.94. What is the ratio of the Amount spent (in US$) in St. Kitts and Nevis in 2011 to that in 2013?
Provide a short and direct response. 0.93. What is the ratio of the Amount spent (in US$) of OECD members in 2012 to that in 2013?
Keep it short and to the point. 0.93. What is the ratio of the Amount spent (in US$) in Mozambique in 2012 to that in 2013?
Keep it short and to the point. 1.04. What is the ratio of the Amount spent (in US$) in St. Kitts and Nevis in 2012 to that in 2013?
Ensure brevity in your answer.  0.94. What is the difference between the highest and the second highest Amount spent (in US$) of OECD members?
Provide a succinct answer. 4.70e+1. What is the difference between the highest and the second highest Amount spent (in US$) in Mozambique?
Give a very brief answer. 9.00e+06. What is the difference between the highest and the second highest Amount spent (in US$) in St. Kitts and Nevis?
Your answer should be very brief. 7.00e+06. What is the difference between the highest and the lowest Amount spent (in US$) of OECD members?
Provide a succinct answer. 1.95e+11. What is the difference between the highest and the lowest Amount spent (in US$) in Mozambique?
Your response must be concise. 1.10e+08. What is the difference between the highest and the lowest Amount spent (in US$) in St. Kitts and Nevis?
Keep it short and to the point. 4.90e+07. 